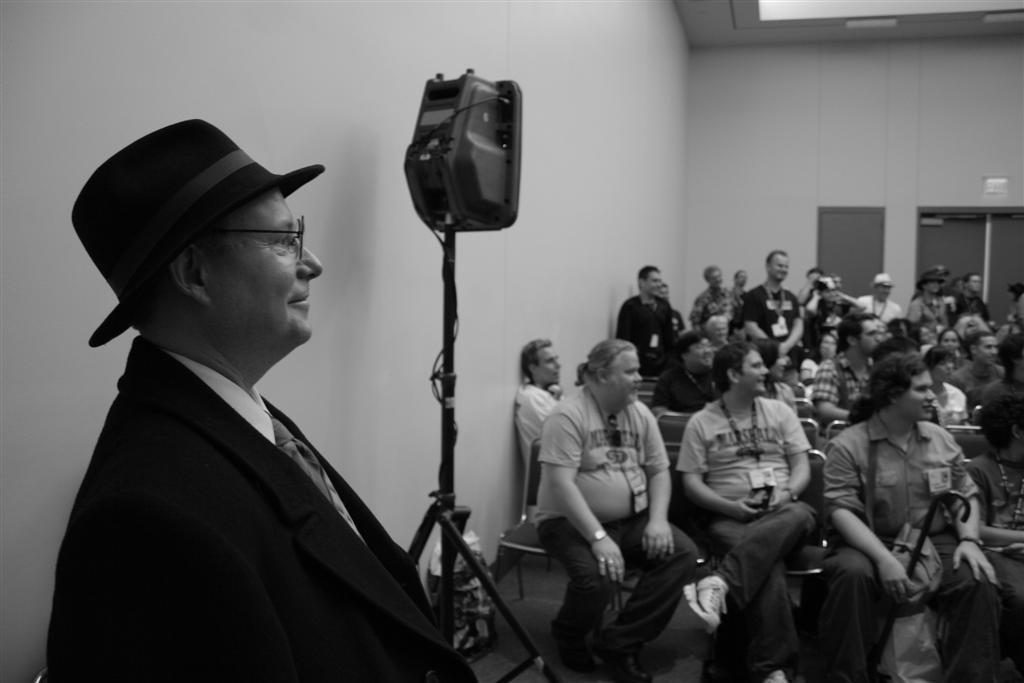Describe this image in one or two sentences. On the left side a man is there, he wore coat, shirt, tie, hat. On the right side few people are sitting on the chairs and looking at that side. This is the wall. 